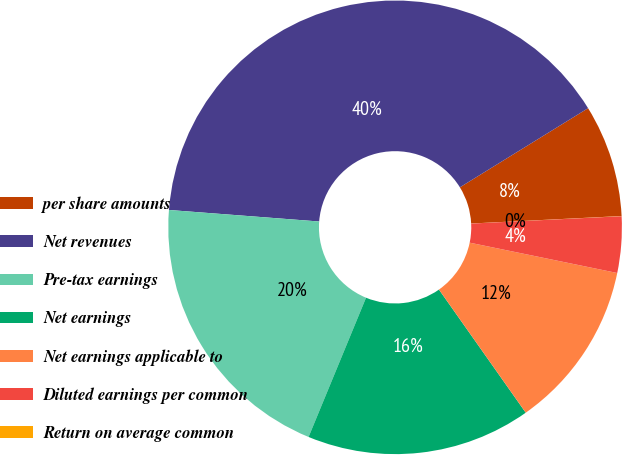<chart> <loc_0><loc_0><loc_500><loc_500><pie_chart><fcel>per share amounts<fcel>Net revenues<fcel>Pre-tax earnings<fcel>Net earnings<fcel>Net earnings applicable to<fcel>Diluted earnings per common<fcel>Return on average common<nl><fcel>8.01%<fcel>39.98%<fcel>19.99%<fcel>16.0%<fcel>12.0%<fcel>4.01%<fcel>0.01%<nl></chart> 